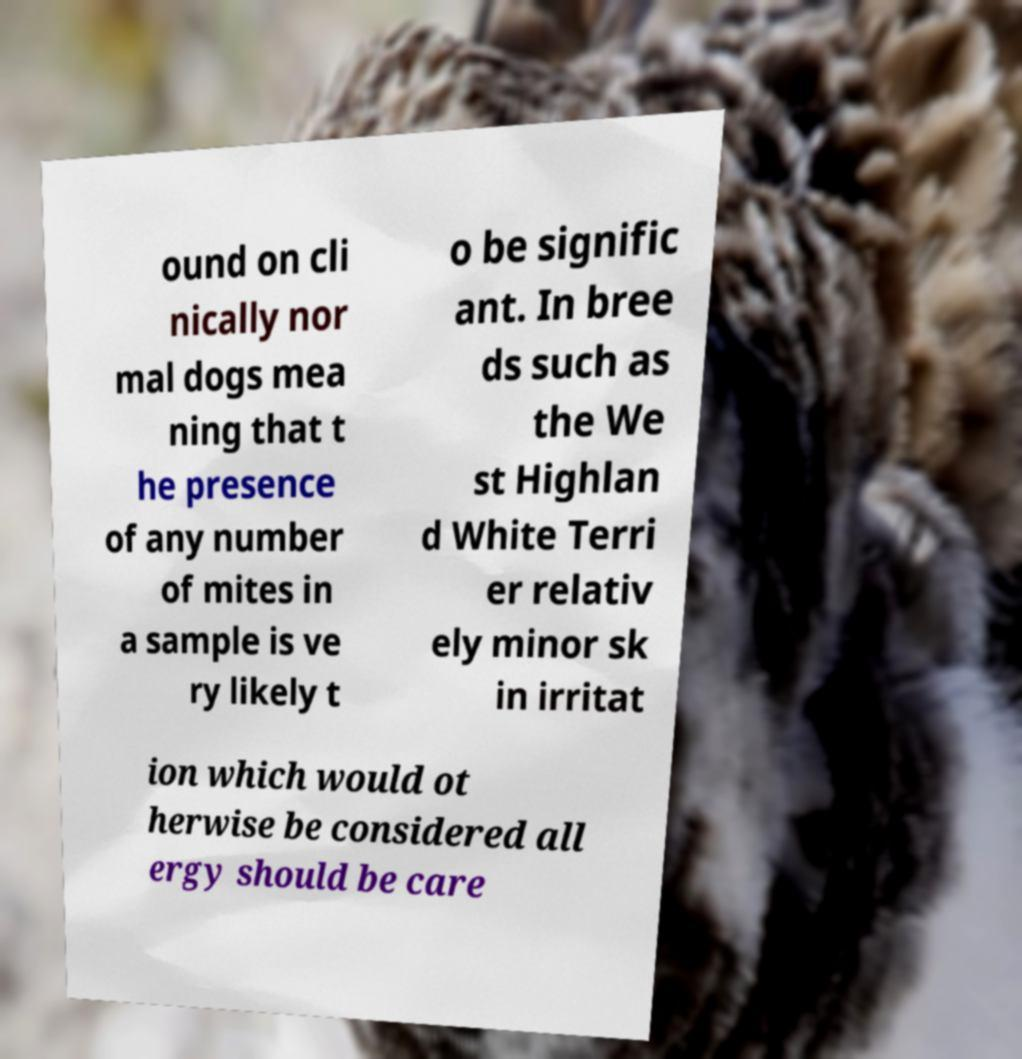Can you read and provide the text displayed in the image?This photo seems to have some interesting text. Can you extract and type it out for me? ound on cli nically nor mal dogs mea ning that t he presence of any number of mites in a sample is ve ry likely t o be signific ant. In bree ds such as the We st Highlan d White Terri er relativ ely minor sk in irritat ion which would ot herwise be considered all ergy should be care 